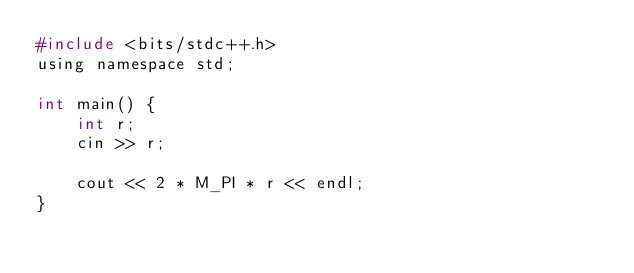Convert code to text. <code><loc_0><loc_0><loc_500><loc_500><_C_>#include <bits/stdc++.h>
using namespace std;

int main() {
	int r;
	cin >> r;

	cout << 2 * M_PI * r << endl;
}</code> 